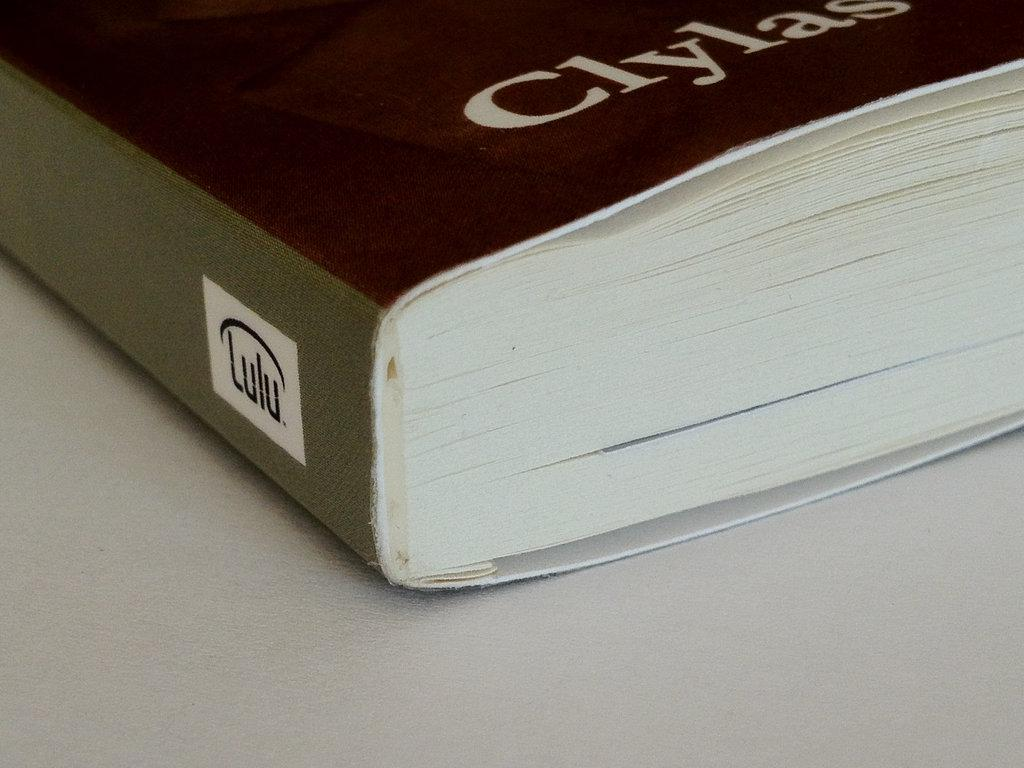<image>
Create a compact narrative representing the image presented. A black book with Clylas written on the cover. 